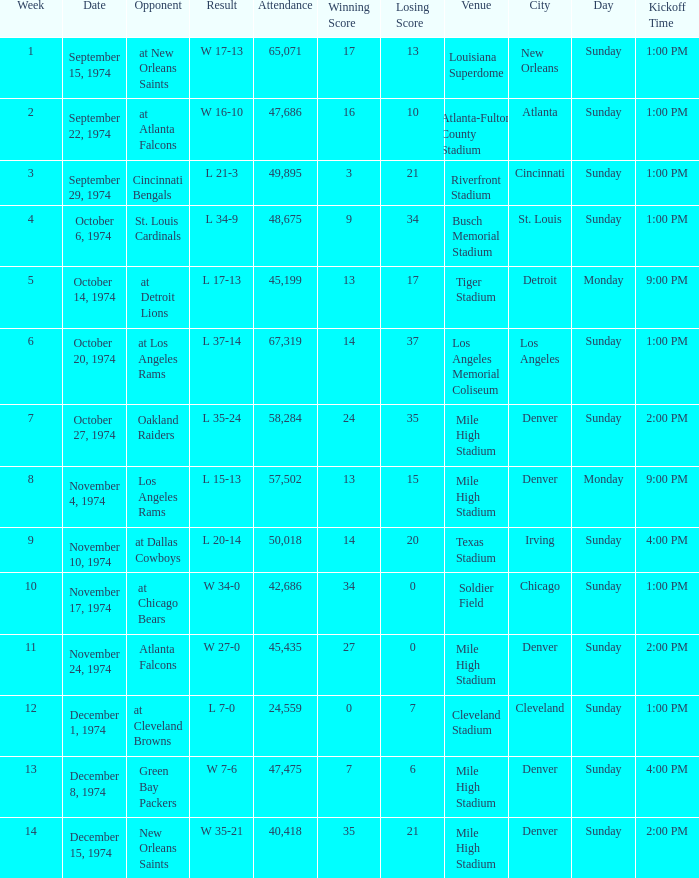What was the attendance when they played at Detroit Lions? 45199.0. 